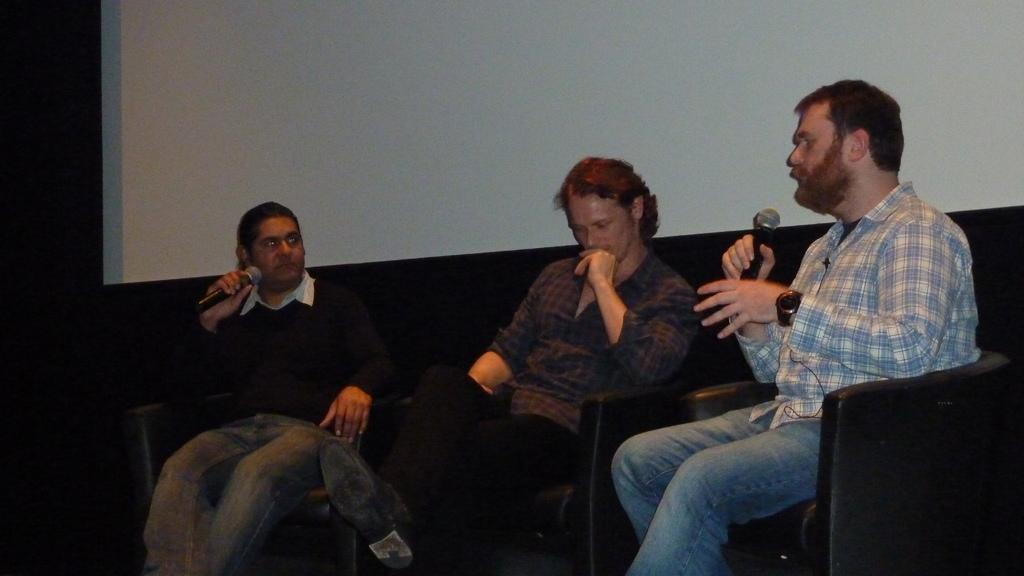Could you give a brief overview of what you see in this image? In this image, there are a few people sitting on the sofas. Among them, two people are holding microphones. In the background, we can see a white colored object. 